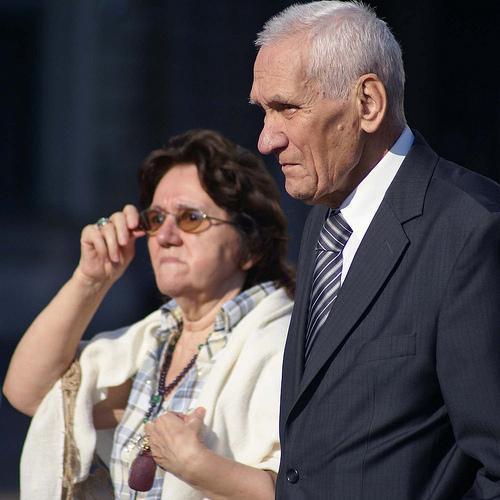How many individuals are wearing neckties?
Give a very brief answer. 1. How many rings are on the woman's right hand?
Give a very brief answer. 1. 